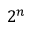Convert formula to latex. <formula><loc_0><loc_0><loc_500><loc_500>2 ^ { n }</formula> 